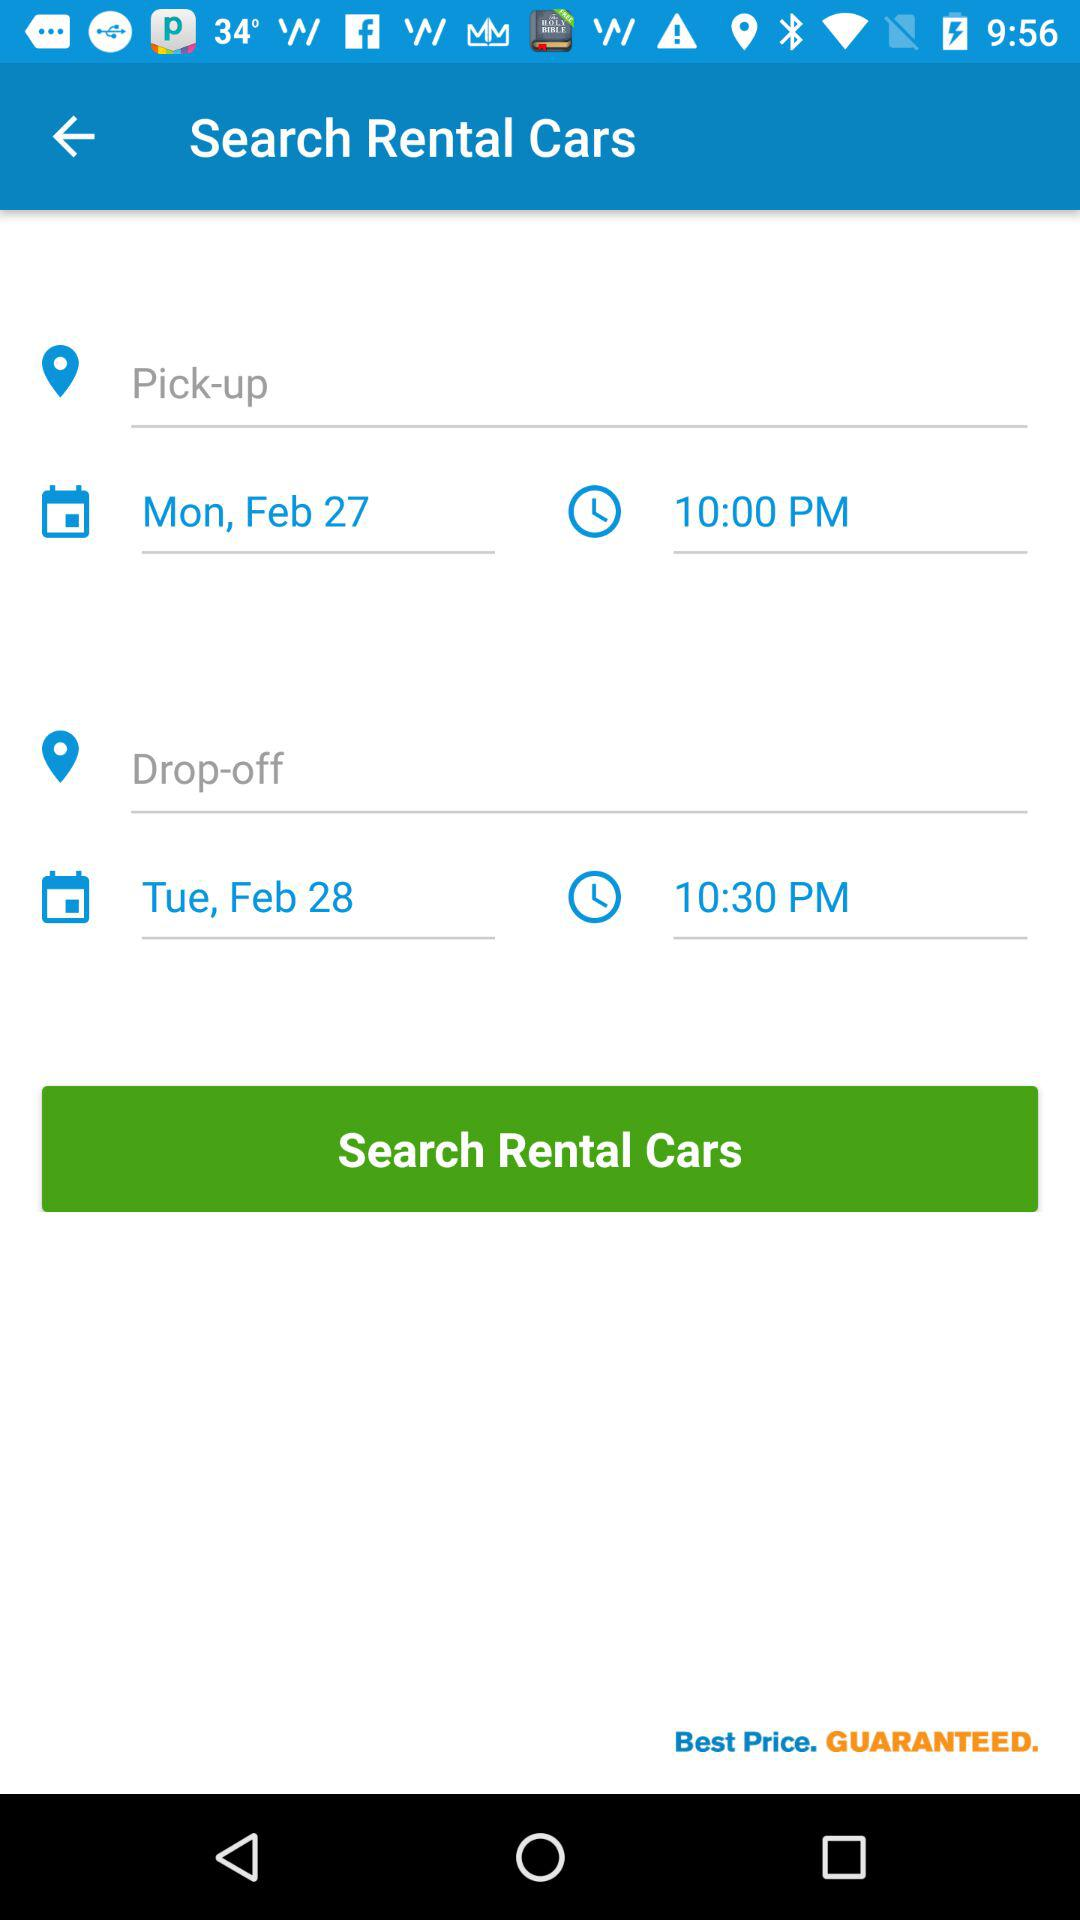What is the time of the drop-off? The time of the drop-off is 10:30 PM. 